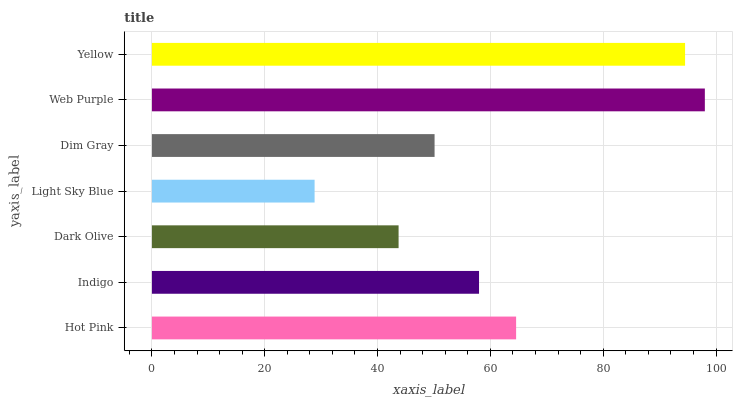Is Light Sky Blue the minimum?
Answer yes or no. Yes. Is Web Purple the maximum?
Answer yes or no. Yes. Is Indigo the minimum?
Answer yes or no. No. Is Indigo the maximum?
Answer yes or no. No. Is Hot Pink greater than Indigo?
Answer yes or no. Yes. Is Indigo less than Hot Pink?
Answer yes or no. Yes. Is Indigo greater than Hot Pink?
Answer yes or no. No. Is Hot Pink less than Indigo?
Answer yes or no. No. Is Indigo the high median?
Answer yes or no. Yes. Is Indigo the low median?
Answer yes or no. Yes. Is Light Sky Blue the high median?
Answer yes or no. No. Is Dark Olive the low median?
Answer yes or no. No. 